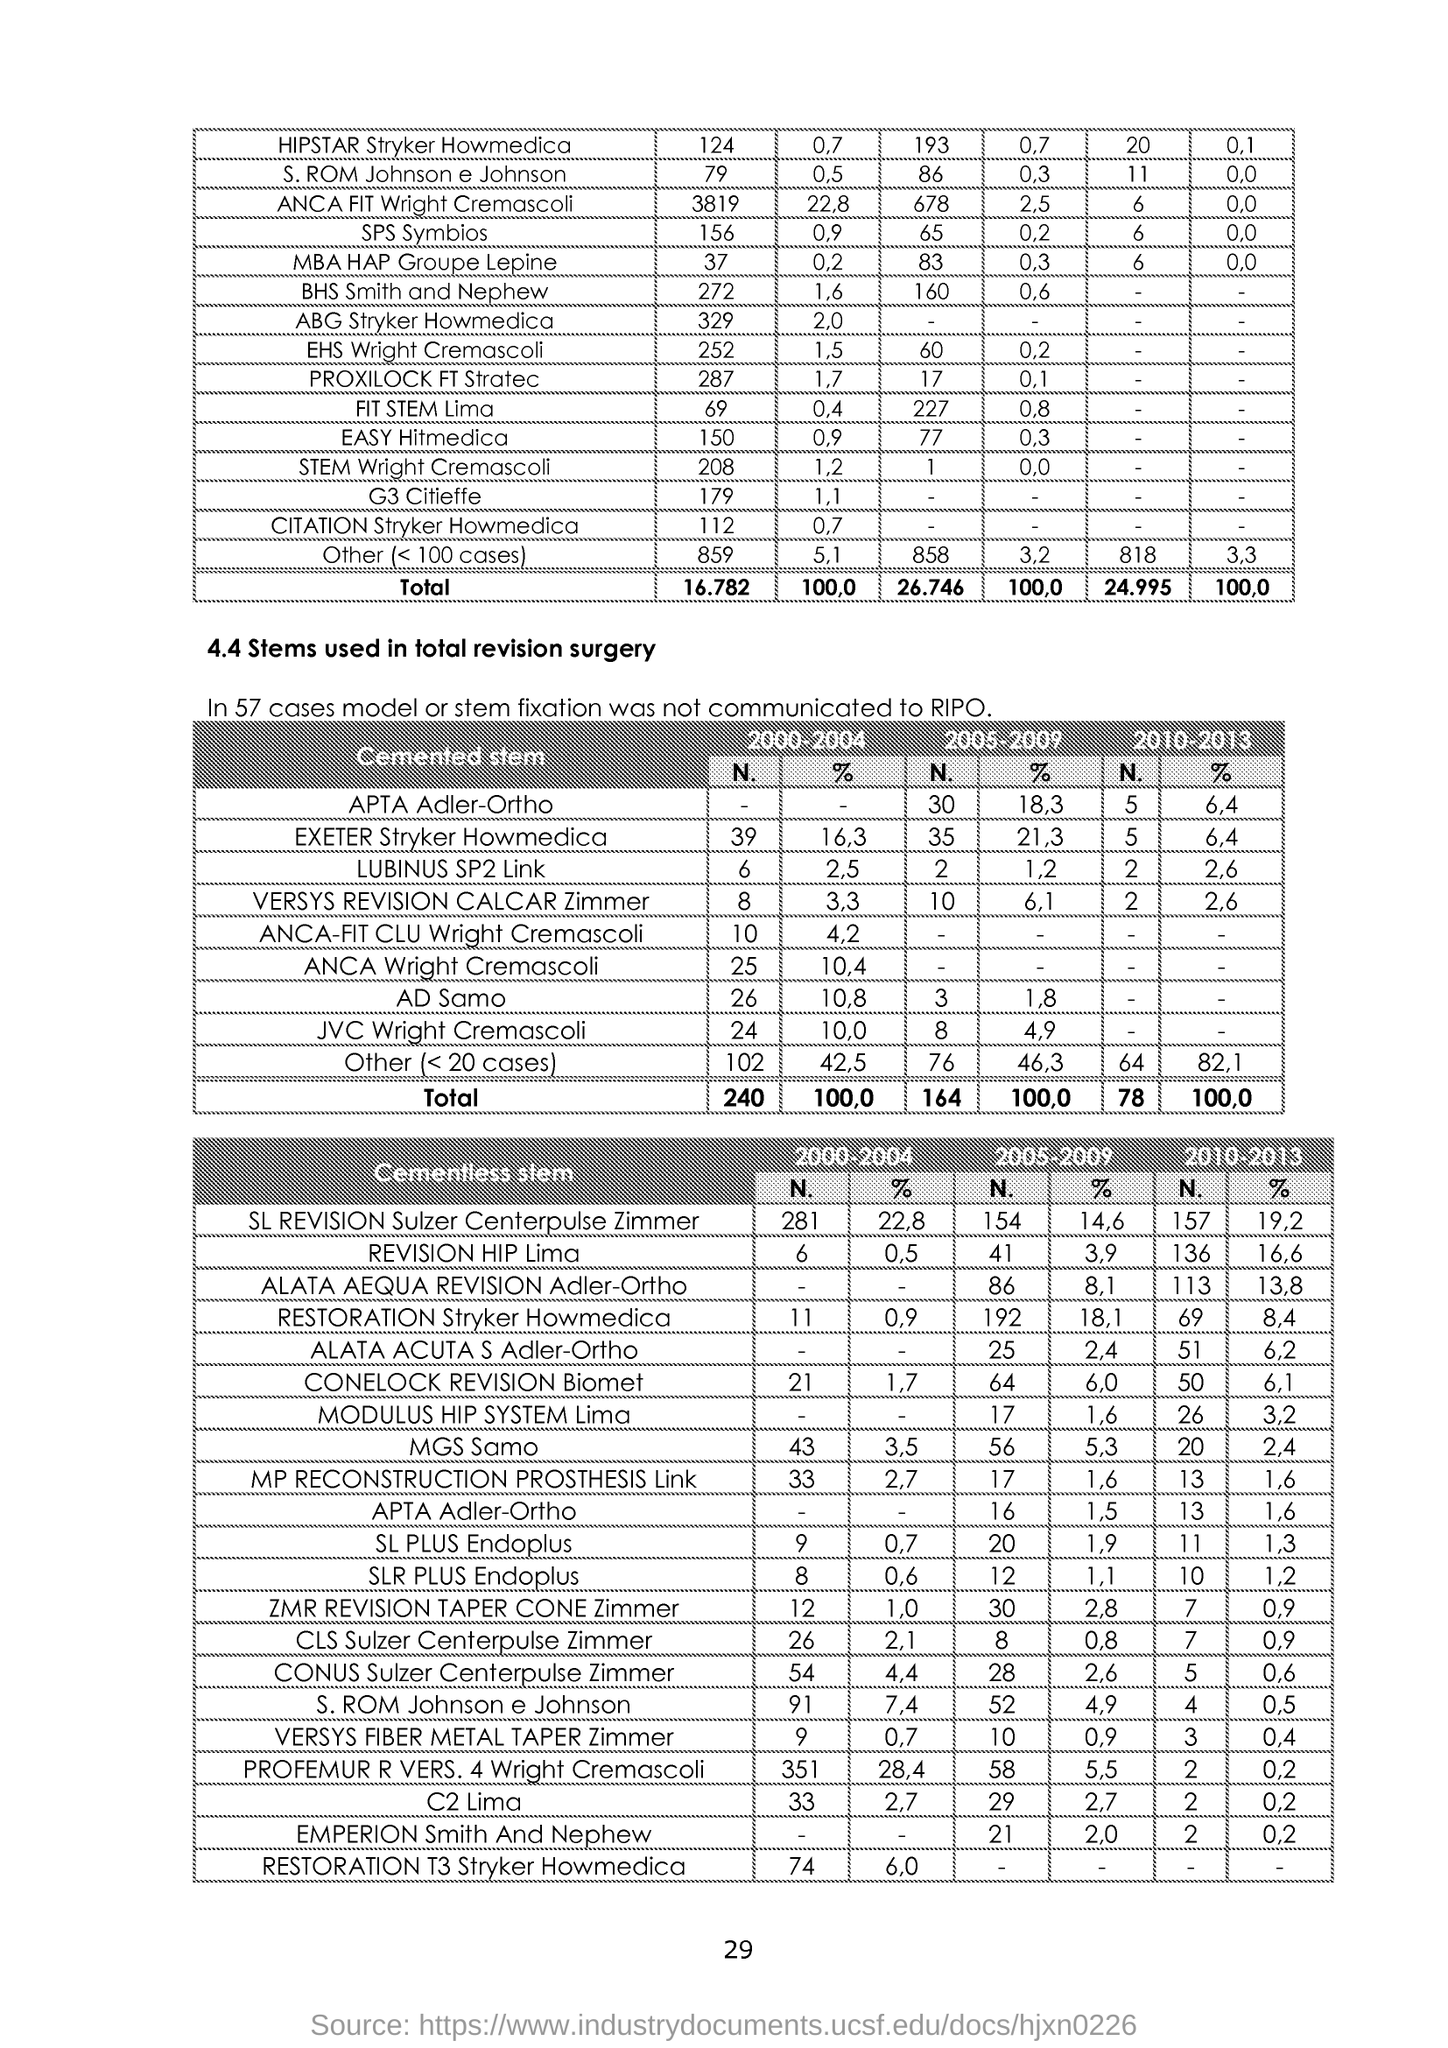What is the Page Number?
Offer a very short reply. 29. 